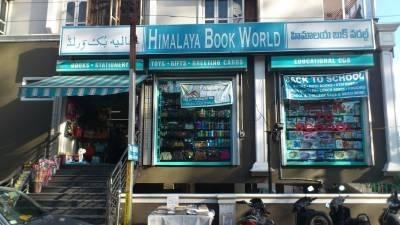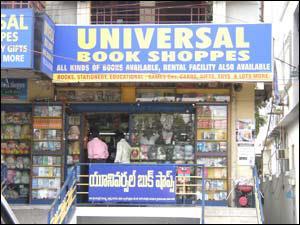The first image is the image on the left, the second image is the image on the right. Analyze the images presented: Is the assertion "Both photos show the exterior of a book shop." valid? Answer yes or no. Yes. 